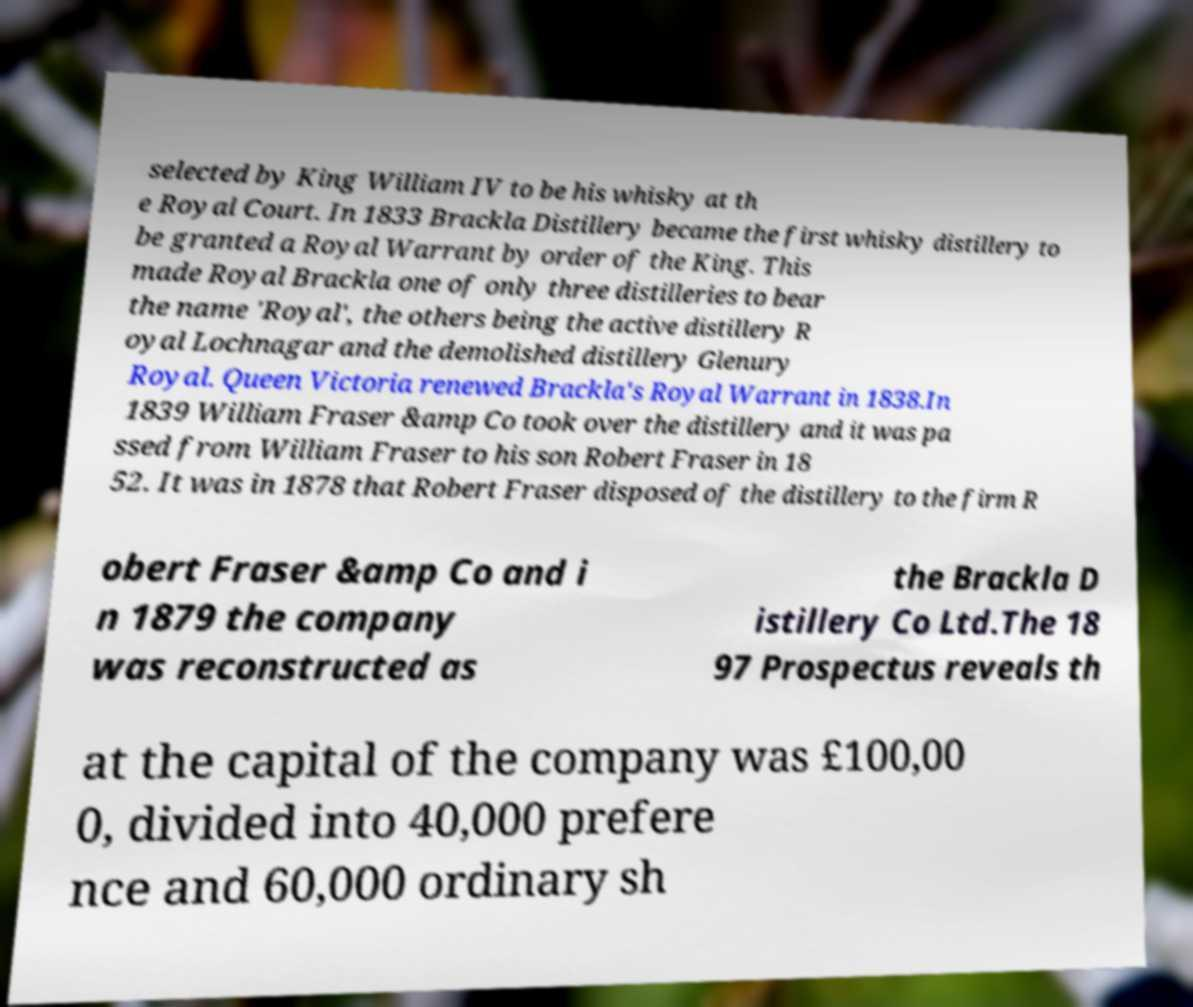Please identify and transcribe the text found in this image. selected by King William IV to be his whisky at th e Royal Court. In 1833 Brackla Distillery became the first whisky distillery to be granted a Royal Warrant by order of the King. This made Royal Brackla one of only three distilleries to bear the name 'Royal', the others being the active distillery R oyal Lochnagar and the demolished distillery Glenury Royal. Queen Victoria renewed Brackla's Royal Warrant in 1838.In 1839 William Fraser &amp Co took over the distillery and it was pa ssed from William Fraser to his son Robert Fraser in 18 52. It was in 1878 that Robert Fraser disposed of the distillery to the firm R obert Fraser &amp Co and i n 1879 the company was reconstructed as the Brackla D istillery Co Ltd.The 18 97 Prospectus reveals th at the capital of the company was £100,00 0, divided into 40,000 prefere nce and 60,000 ordinary sh 